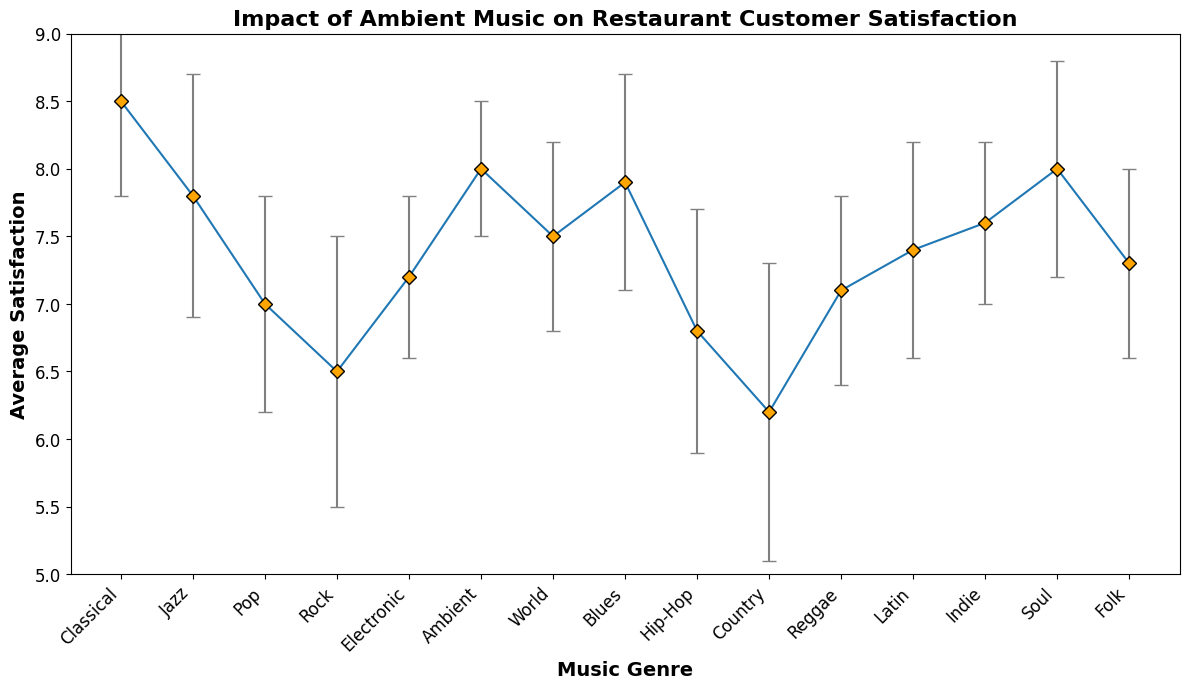What music genre has the highest average satisfaction? The figure shows the average satisfaction for various music genres. The genre with the highest average satisfaction will have the highest point on the y-axis.
Answer: Classical Which music genre has a higher average satisfaction: Jazz or Pop? To compare the average satisfaction between Jazz and Pop, locate the points representing these genres on the y-axis and compare their heights. Jazz has a higher point than Pop.
Answer: Jazz What is the difference in average satisfaction between Classical and Rock? To find the difference, locate the average satisfaction for Classical and Rock on the y-axis. Classical is at 8.5 and Rock is at 6.5. Subtract the two values: 8.5 - 6.5 = 2.0
Answer: 2.0 Which genre has the largest standard deviation in customer satisfaction? The standard deviation is represented by the length of the error bars. The genre with the longest error bar has the largest standard deviation.
Answer: Country What is the average satisfaction of Ambient music? The figure shows the average satisfaction for Ambient music by locating the Ambient label on the x-axis and checking its point on the y-axis.
Answer: 8.0 Which three genres have the highest average satisfaction? To find the top three genres, compare the heights of the points on the y-axis. The highest points indicate the highest average satisfaction. The top three are Classical, Ambient, and Soul.
Answer: Classical, Ambient, Soul What is the range (difference between highest and lowest average satisfaction) of customer satisfaction across all music genres? To find the range, locate the highest and lowest points on the y-axis. The highest point is Classical at 8.5 and the lowest point is Country at 6.2. Subtract the lowest from the highest: 8.5 - 6.2 = 2.3
Answer: 2.3 Is the average satisfaction for Hip-Hop greater than for Country? Compare the average satisfaction points for Hip-Hop and Country on the y-axis. Hip-Hop has an average satisfaction of 6.8, which is greater than Country's 6.2.
Answer: Yes Which genres have an average satisfaction above 7.5? Examine the average satisfaction points on the y-axis and identify those above 7.5. They are Classical, Jazz, Ambient, Blues, Soul, and Indie.
Answer: Classical, Jazz, Ambient, Blues, Soul, Indie How does the standard deviation of Pop compare to Electronic? Compare the lengths of the error bars for Pop and Electronic. The standard deviation for Pop is represented by a longer error bar (0.8) than Electronic (0.6).
Answer: Pop has a larger standard deviation 